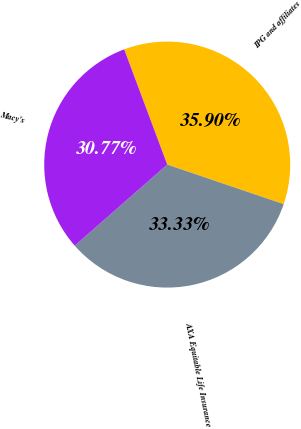<chart> <loc_0><loc_0><loc_500><loc_500><pie_chart><fcel>IPG and affiliates<fcel>AXA Equitable Life Insurance<fcel>Macy's<nl><fcel>35.9%<fcel>33.33%<fcel>30.77%<nl></chart> 